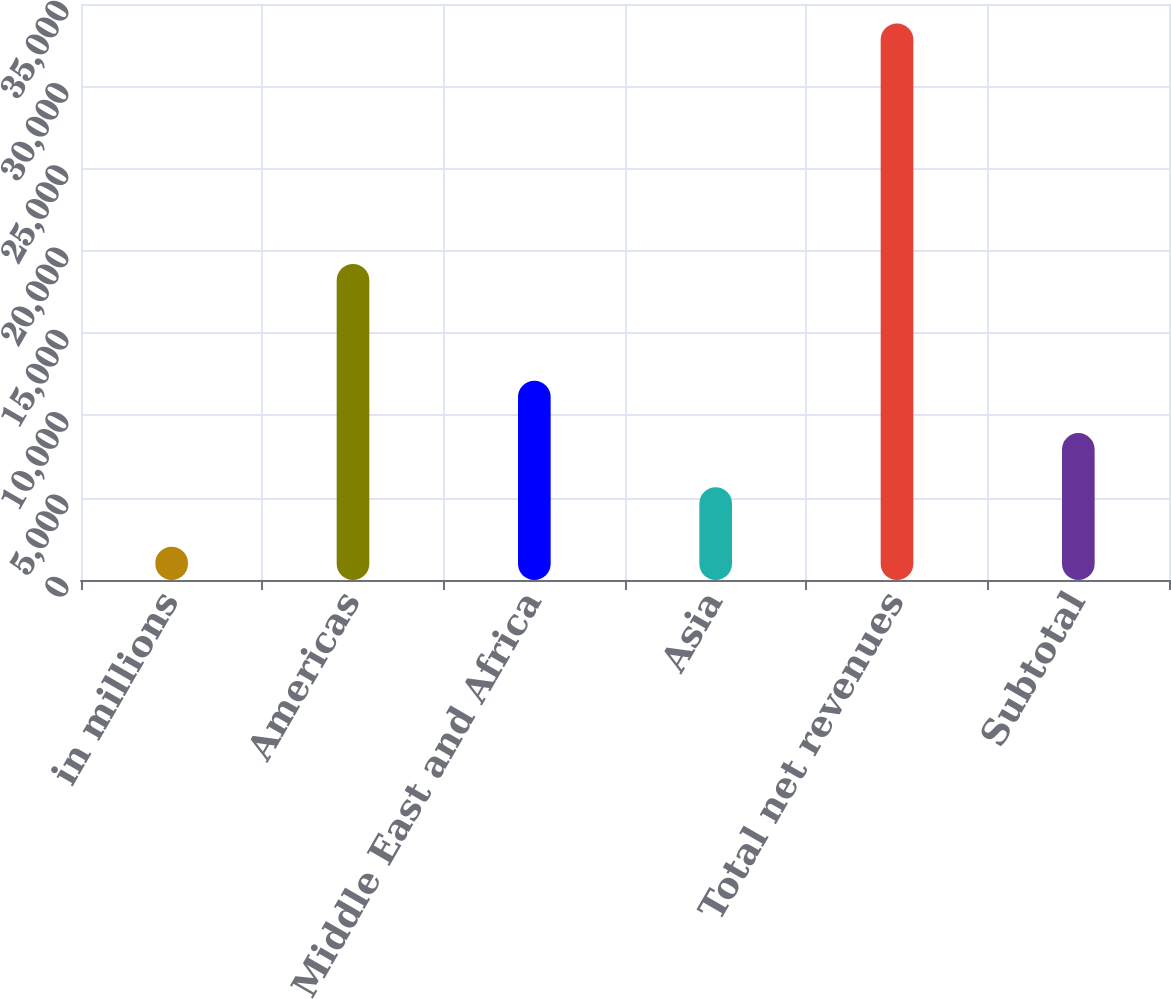Convert chart to OTSL. <chart><loc_0><loc_0><loc_500><loc_500><bar_chart><fcel>in millions<fcel>Americas<fcel>Europe Middle East and Africa<fcel>Asia<fcel>Total net revenues<fcel>Subtotal<nl><fcel>2015<fcel>19202<fcel>12106.5<fcel>5637<fcel>33820<fcel>8926<nl></chart> 